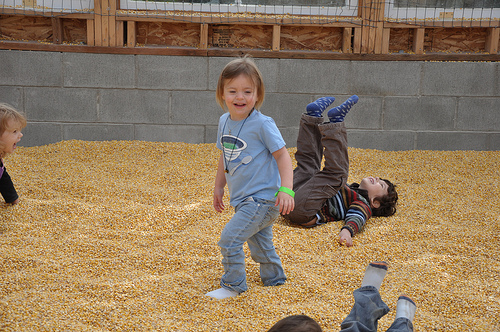<image>
Is the corn under the child? Yes. The corn is positioned underneath the child, with the child above it in the vertical space. 